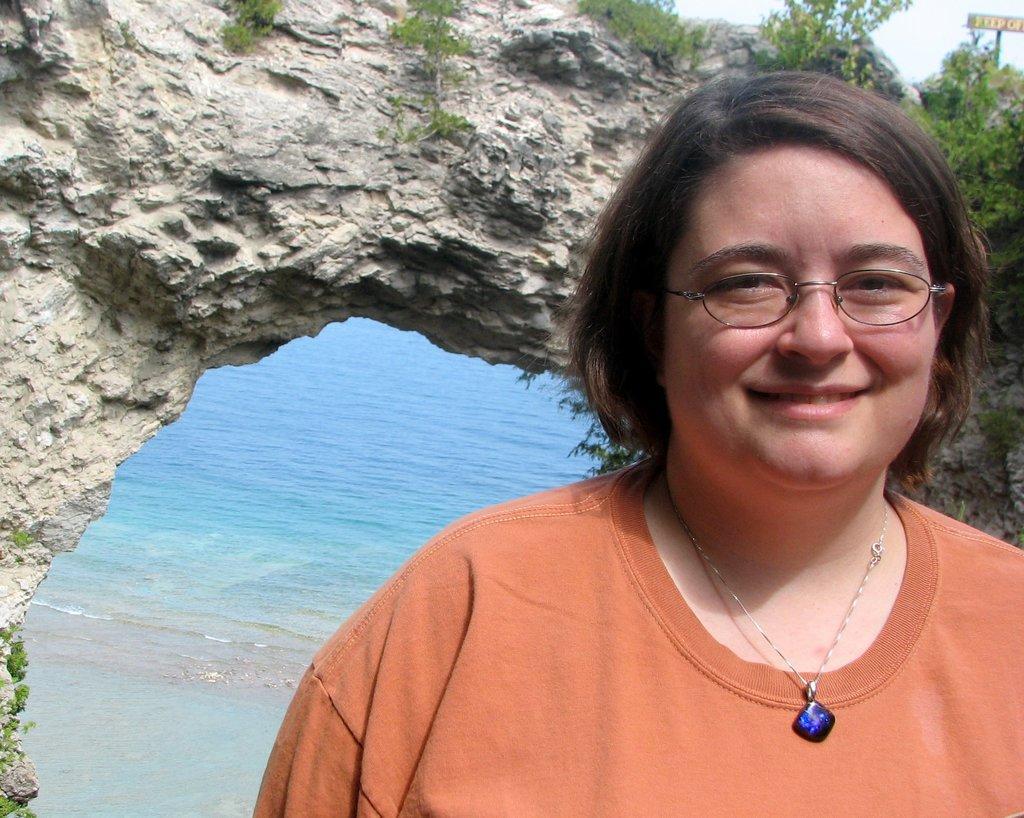How would you summarize this image in a sentence or two? In the foreground of the picture there is a woman wearing spectacles and and orange t-shirt. In the center there are plants and a rock. In the background there is water. 